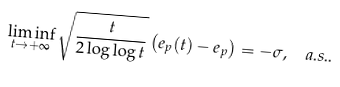Convert formula to latex. <formula><loc_0><loc_0><loc_500><loc_500>\liminf _ { t \rightarrow + \infty } \sqrt { \frac { t } { 2 \log \log t } } \left ( e _ { p } ( t ) - e _ { p } \right ) = - \sigma , \ \ a . s . .</formula> 